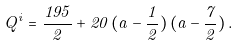Convert formula to latex. <formula><loc_0><loc_0><loc_500><loc_500>Q ^ { i } = \frac { 1 9 5 } { 2 } + 2 0 \, ( a - \frac { 1 } { 2 } ) \, ( a - \frac { 7 } { 2 } ) \, .</formula> 